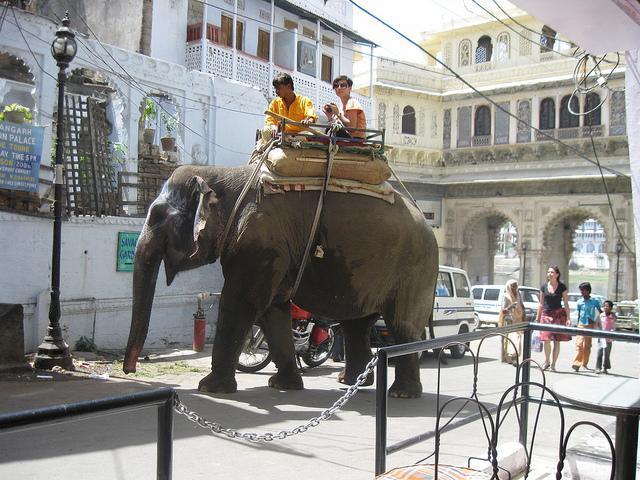How many people are riding the elephant?
Give a very brief answer. 2. How many elephants?
Give a very brief answer. 1. How many animals are in the picture?
Give a very brief answer. 1. How many people are in the photo?
Give a very brief answer. 2. How many light blue umbrellas are in the image?
Give a very brief answer. 0. 